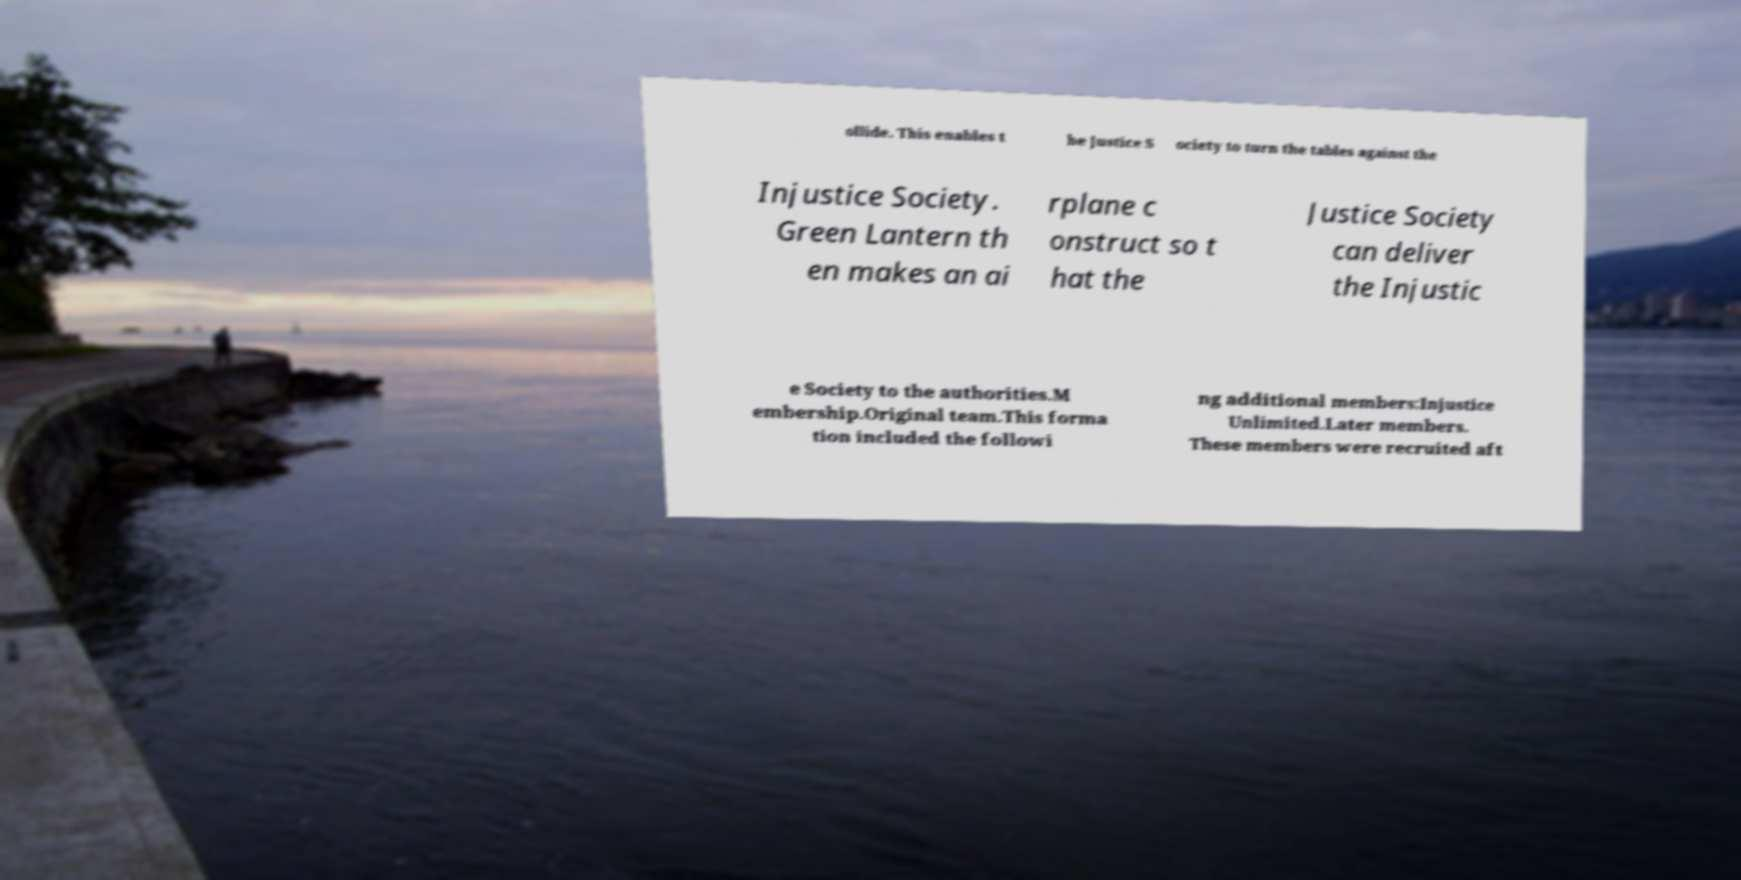Can you accurately transcribe the text from the provided image for me? ollide. This enables t he Justice S ociety to turn the tables against the Injustice Society. Green Lantern th en makes an ai rplane c onstruct so t hat the Justice Society can deliver the Injustic e Society to the authorities.M embership.Original team.This forma tion included the followi ng additional members:Injustice Unlimited.Later members. These members were recruited aft 